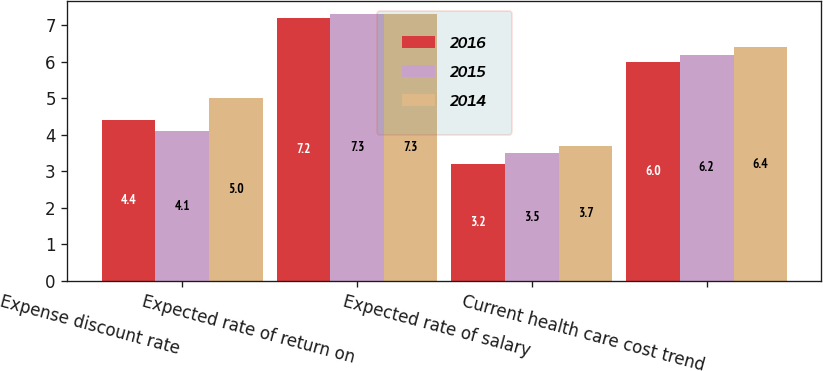Convert chart to OTSL. <chart><loc_0><loc_0><loc_500><loc_500><stacked_bar_chart><ecel><fcel>Expense discount rate<fcel>Expected rate of return on<fcel>Expected rate of salary<fcel>Current health care cost trend<nl><fcel>2016<fcel>4.4<fcel>7.2<fcel>3.2<fcel>6<nl><fcel>2015<fcel>4.1<fcel>7.3<fcel>3.5<fcel>6.2<nl><fcel>2014<fcel>5<fcel>7.3<fcel>3.7<fcel>6.4<nl></chart> 